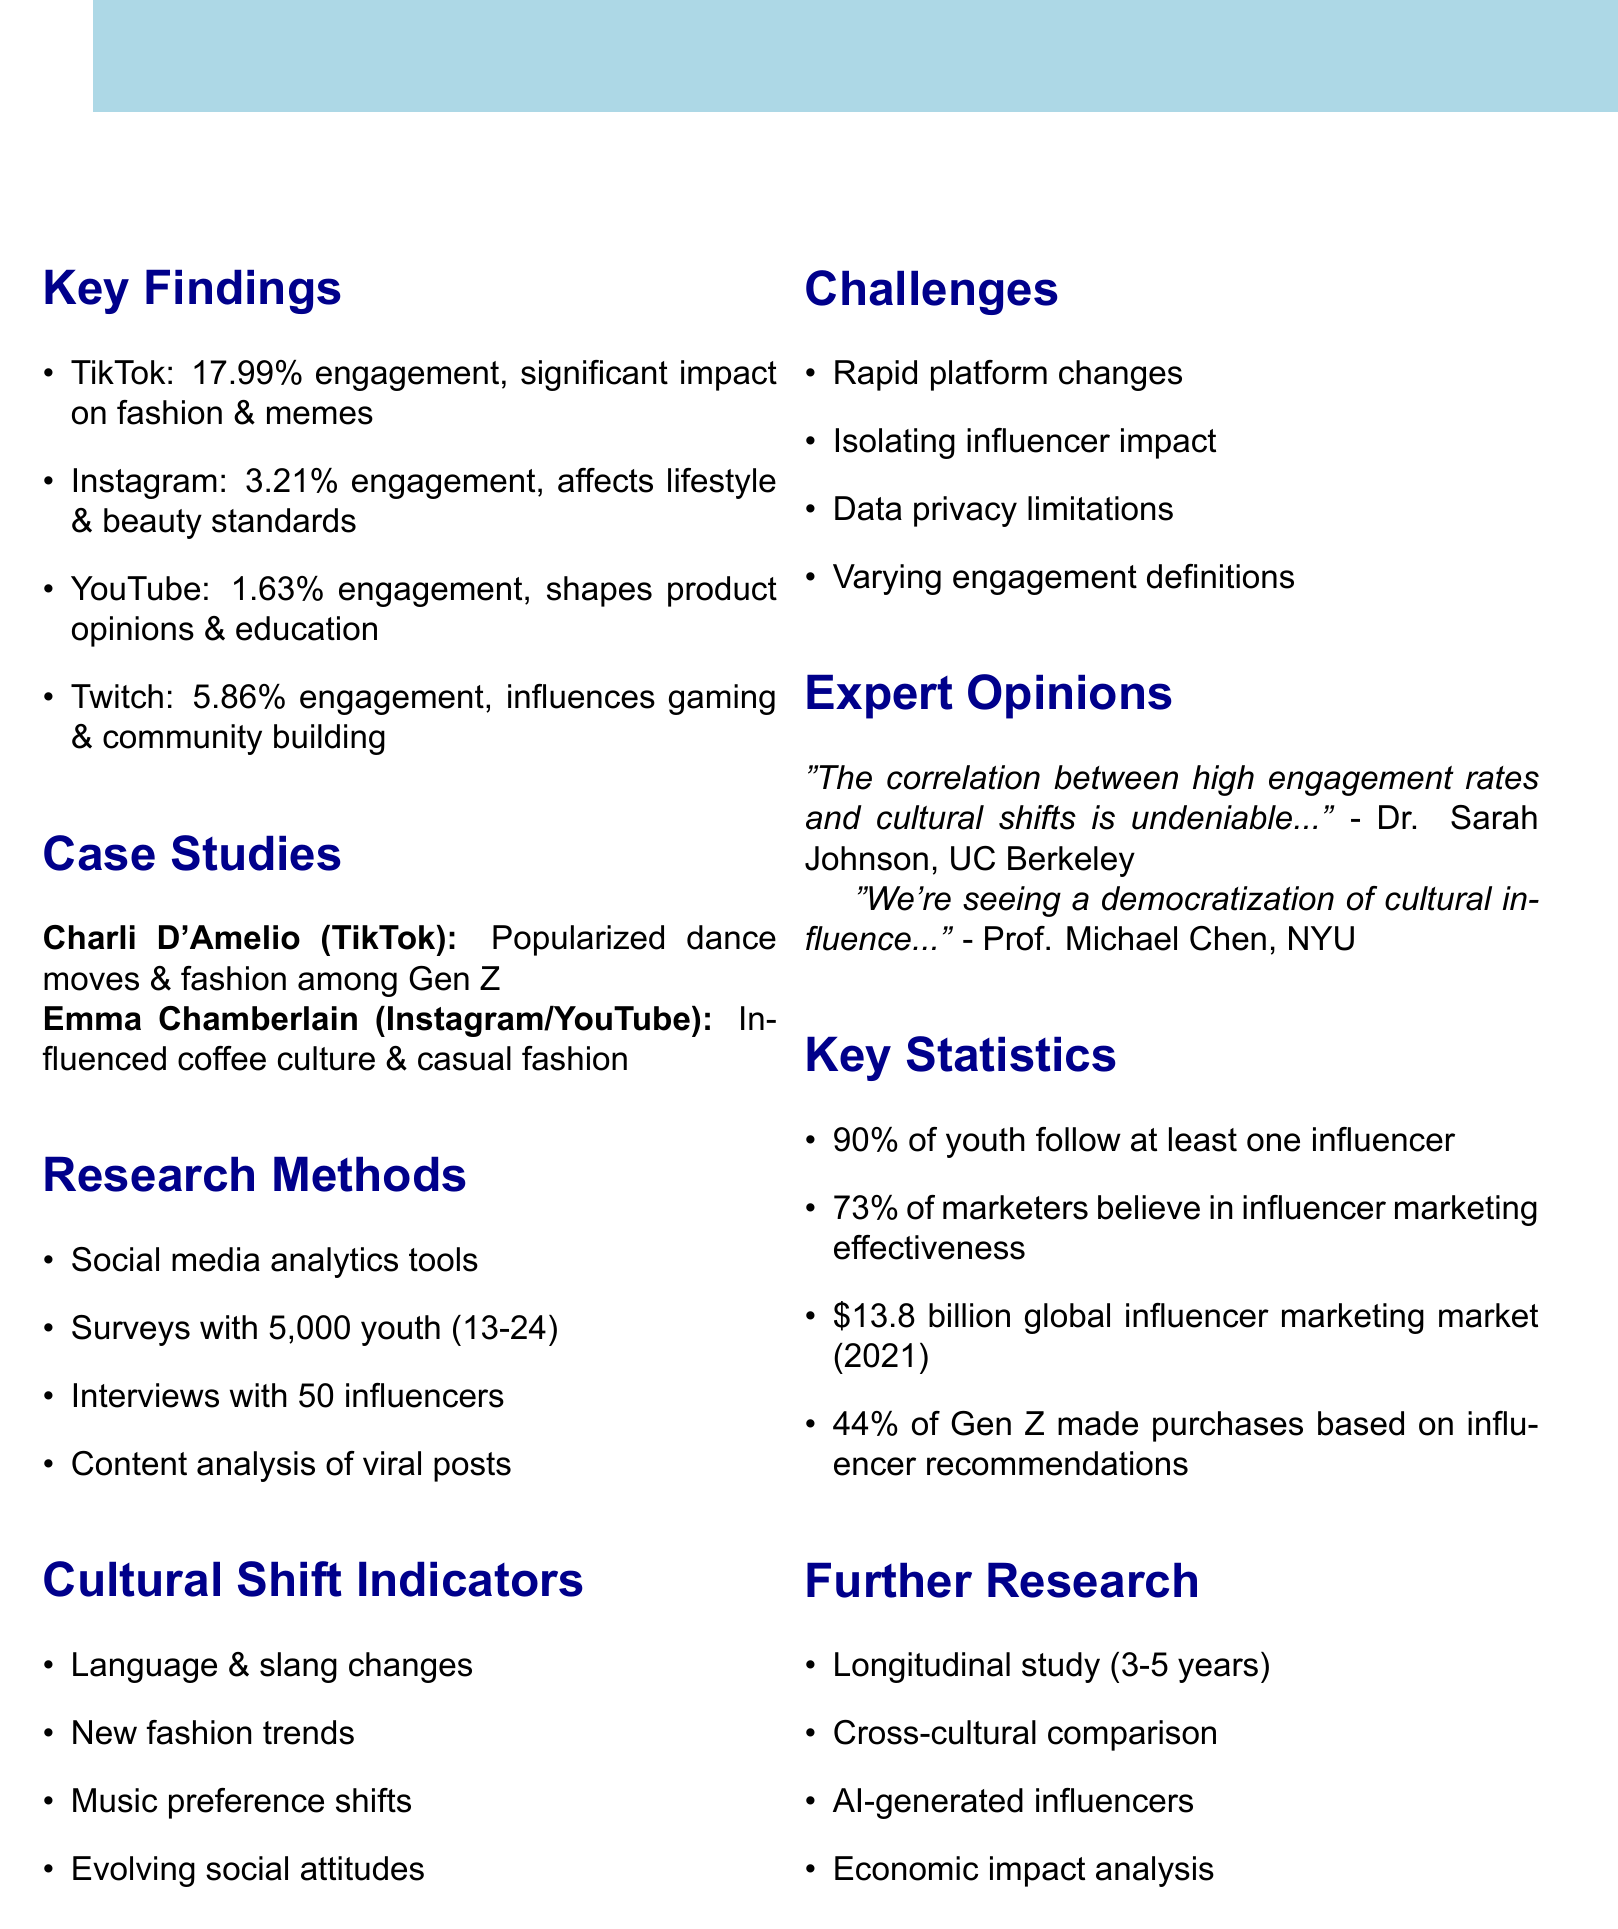What is the engagement rate of TikTok? The engagement rate for TikTok is mentioned as 17.99%.
Answer: 17.99% Which platform has a significant influence on fashion trends? The document states TikTok has a significant influence on fashion trends, among other impacts.
Answer: TikTok Who is the influencer associated with popularizing dance moves on TikTok? Charli D'Amelio is identified as the influencer who popularized specific dance moves on TikTok.
Answer: Charli D'Amelio What percentage of youth follow at least one influencer? The document indicates that 90% of surveyed youth follow at least one influencer.
Answer: 90% What is one challenge mentioned regarding influencer analysis? The challenges include isolating influencer impact from other cultural factors, among others.
Answer: Isolating influencer impact How many in-depth interviews were conducted with influencers? The document specifies that in-depth interviews were conducted with 50 influencers.
Answer: 50 What are the cultural shift indicators listed? The document lists changes in language, fashion trends, music preferences, and attitudes as indicators of cultural shifts.
Answer: Language changes, fashion trends, music preferences, attitudes What is a recommendation for further research mentioned in the document? One recommendation is to conduct a longitudinal study tracking influencer impact over 3-5 years.
Answer: Longitudinal study Which platform is noted for shaping opinions on educational content? YouTube is mentioned as shaping opinions on educational content.
Answer: YouTube 